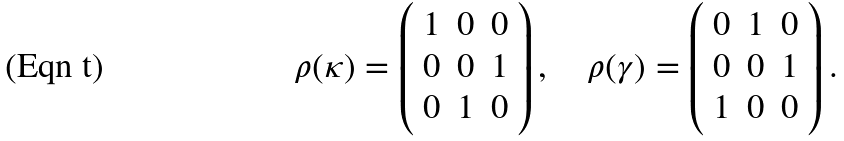<formula> <loc_0><loc_0><loc_500><loc_500>\rho ( \kappa ) = \left ( \begin{array} { c c c } 1 & 0 & 0 \\ 0 & 0 & 1 \\ 0 & 1 & 0 \end{array} \right ) , \quad \rho ( \gamma ) = \left ( \begin{array} { c c c } 0 & 1 & 0 \\ 0 & 0 & 1 \\ 1 & 0 & 0 \end{array} \right ) .</formula> 